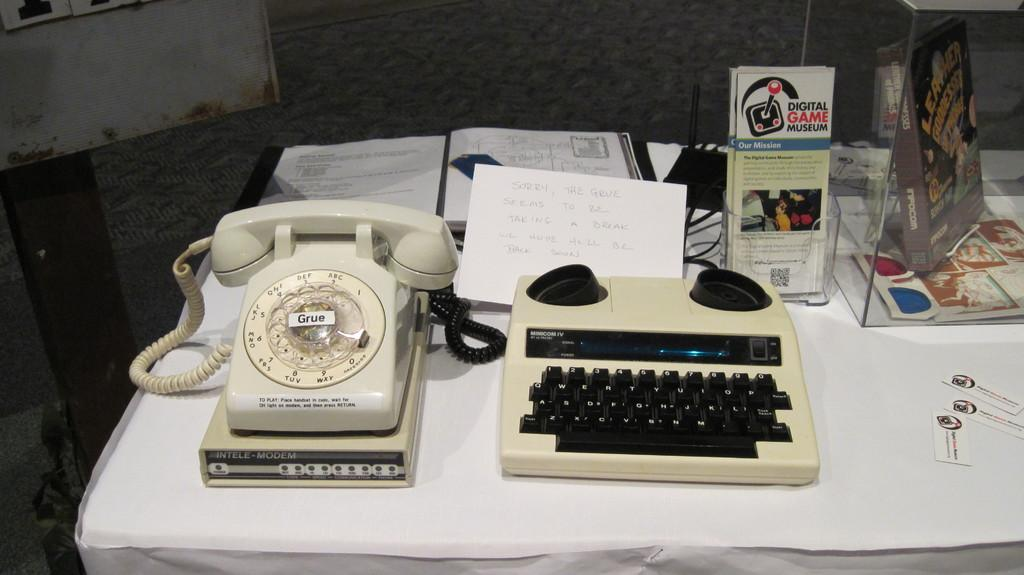What object is located on the left side of the image? There is a telephone on the left side of the image. What can be seen in the middle of the image? There are books in the middle of the image. What type of drug is being sold in the image? There is no reference to any drug in the image; it features a telephone and books. How much wealth is visible in the image? There is no indication of wealth in the image, as it only shows a telephone and books. 